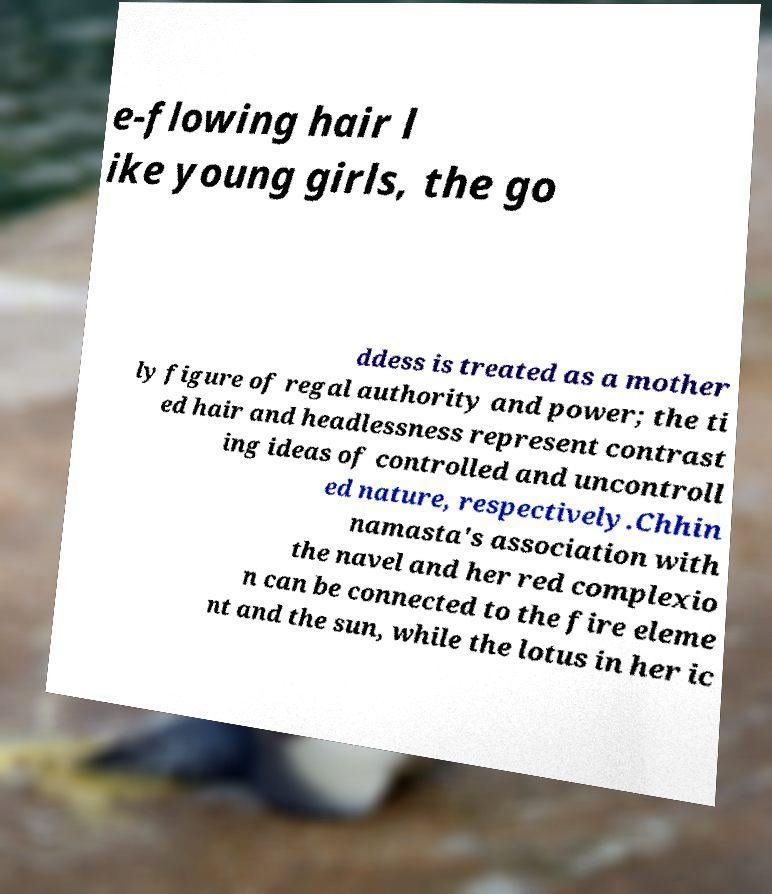What messages or text are displayed in this image? I need them in a readable, typed format. e-flowing hair l ike young girls, the go ddess is treated as a mother ly figure of regal authority and power; the ti ed hair and headlessness represent contrast ing ideas of controlled and uncontroll ed nature, respectively.Chhin namasta's association with the navel and her red complexio n can be connected to the fire eleme nt and the sun, while the lotus in her ic 